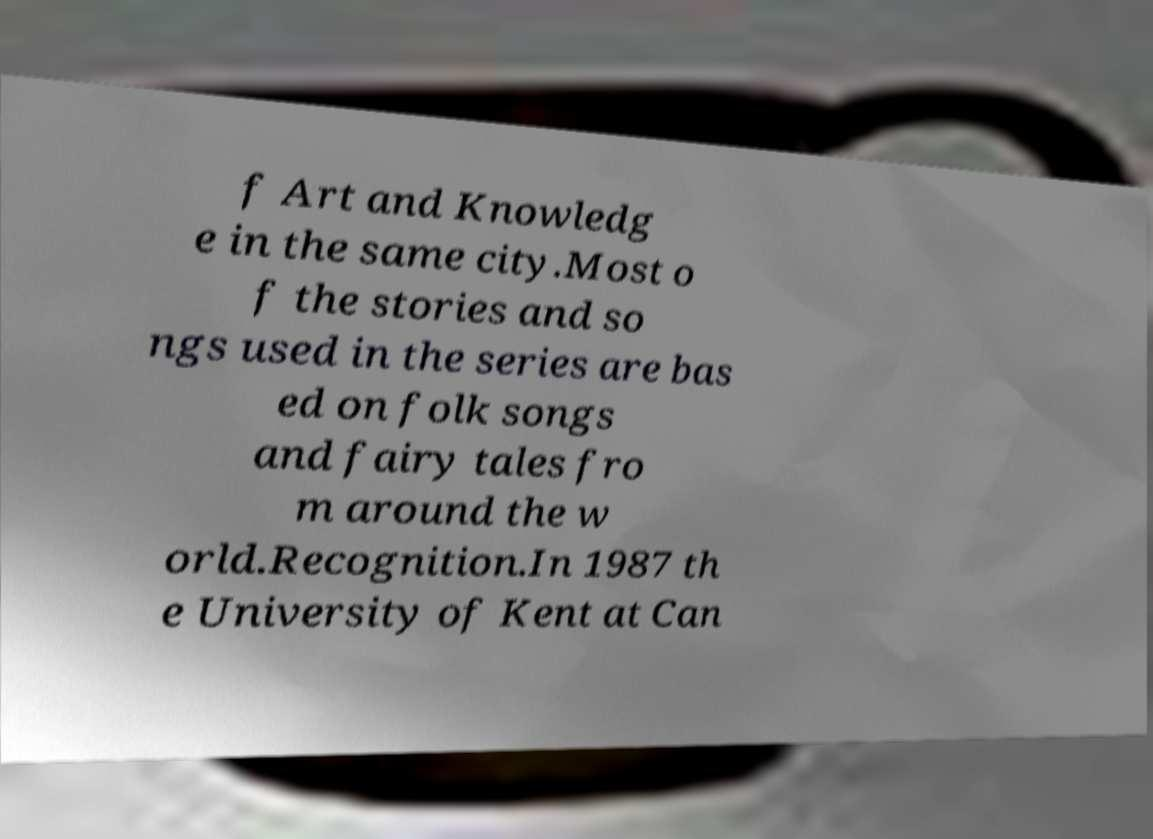Can you accurately transcribe the text from the provided image for me? f Art and Knowledg e in the same city.Most o f the stories and so ngs used in the series are bas ed on folk songs and fairy tales fro m around the w orld.Recognition.In 1987 th e University of Kent at Can 